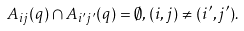<formula> <loc_0><loc_0><loc_500><loc_500>A _ { i j } ( q ) \cap A _ { i ^ { \prime } j ^ { \prime } } ( q ) = \emptyset , ( i , j ) \ne ( i ^ { \prime } , j ^ { \prime } ) .</formula> 